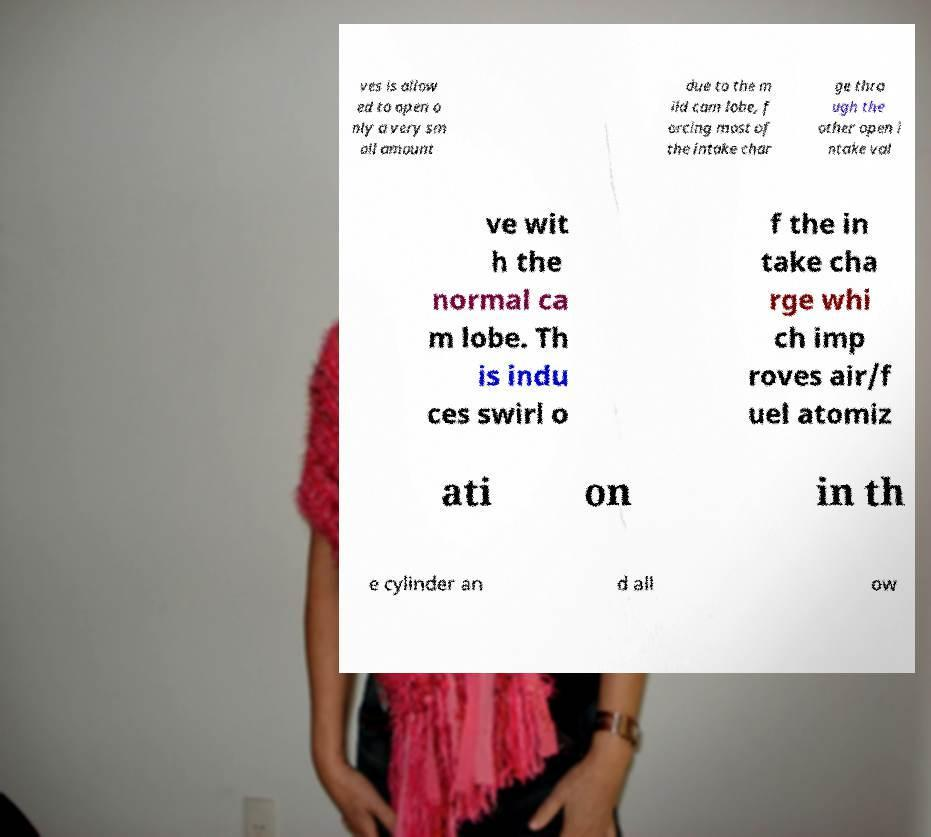Can you accurately transcribe the text from the provided image for me? ves is allow ed to open o nly a very sm all amount due to the m ild cam lobe, f orcing most of the intake char ge thro ugh the other open i ntake val ve wit h the normal ca m lobe. Th is indu ces swirl o f the in take cha rge whi ch imp roves air/f uel atomiz ati on in th e cylinder an d all ow 